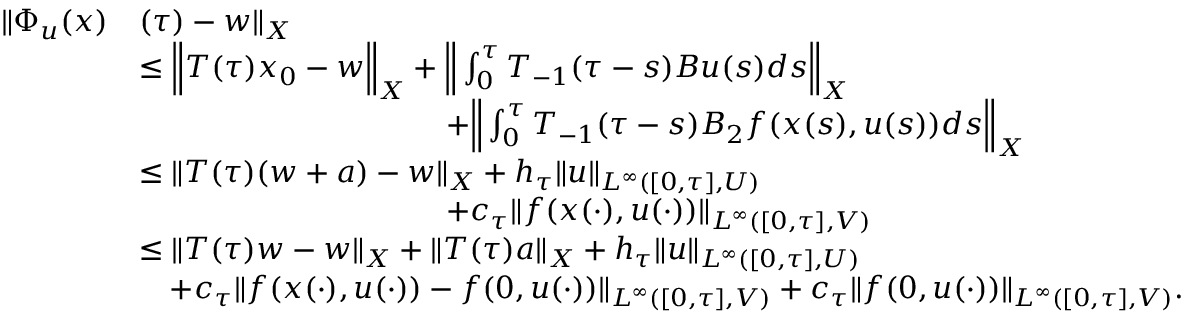Convert formula to latex. <formula><loc_0><loc_0><loc_500><loc_500>\begin{array} { r l } { \| \Phi _ { u } ( x ) } & { ( \tau ) - w \| _ { X } } \\ & { \leq \left \| T ( \tau ) x _ { 0 } - w \right \| _ { X } + \left \| \int _ { 0 } ^ { \tau } T _ { - 1 } ( \tau - s ) B u ( s ) d s \right \| _ { X } } \\ & { \quad + \left \| \int _ { 0 } ^ { \tau } T _ { - 1 } ( \tau - s ) B _ { 2 } f ( x ( s ) , u ( s ) ) d s \right \| _ { X } } \\ & { \leq \| T ( \tau ) ( w + a ) - w \| _ { X } + h _ { \tau } \| u \| _ { L ^ { \infty } ( [ 0 , \tau ] , U ) } } \\ & { \quad + c _ { \tau } \| f ( x ( \cdot ) , u ( \cdot ) ) \| _ { L ^ { \infty } ( [ 0 , \tau ] , V ) } } \\ & { \leq \| T ( \tau ) w - w \| _ { X } + \| T ( \tau ) a \| _ { X } + h _ { \tau } \| u \| _ { L ^ { \infty } ( [ 0 , \tau ] , U ) } } \\ & { \quad + c _ { \tau } \| f ( x ( \cdot ) , u ( \cdot ) ) - f ( 0 , u ( \cdot ) ) \| _ { L ^ { \infty } ( [ 0 , \tau ] , V ) } + c _ { \tau } \| f ( 0 , u ( \cdot ) ) \| _ { L ^ { \infty } ( [ 0 , \tau ] , V ) } . } \end{array}</formula> 